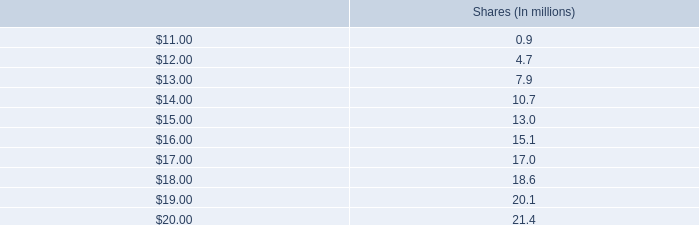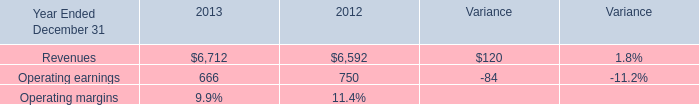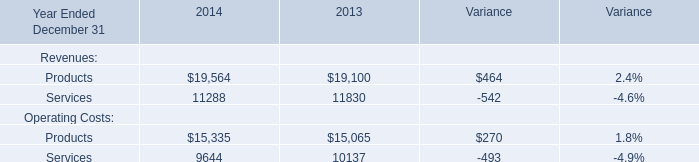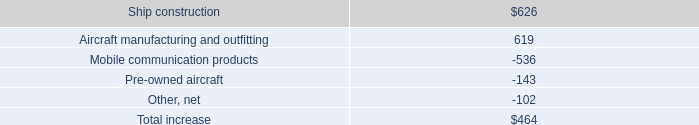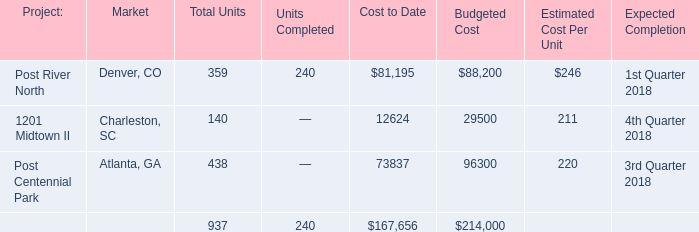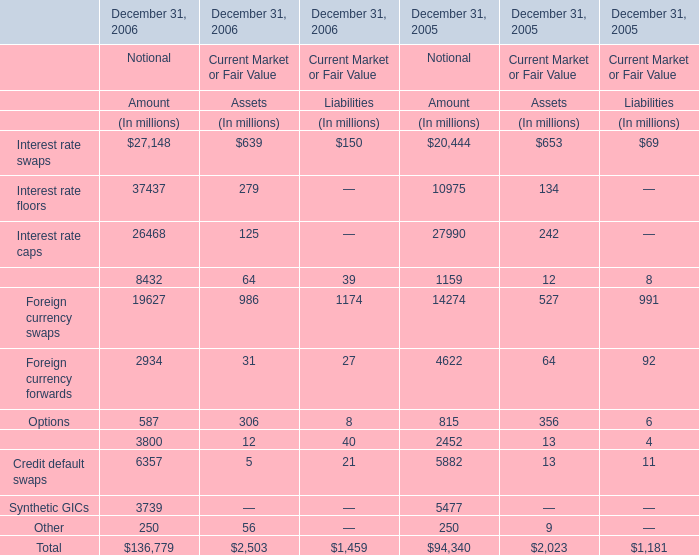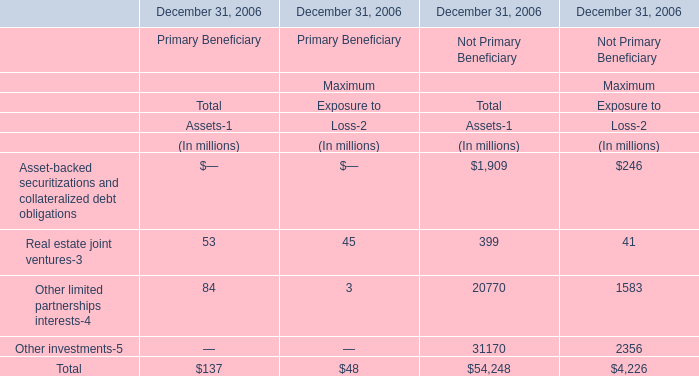Which section is Maximum of Primary Beneficiary the highest? 
Answer: Real estate joint ventures. 